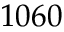<formula> <loc_0><loc_0><loc_500><loc_500>1 0 6 0</formula> 